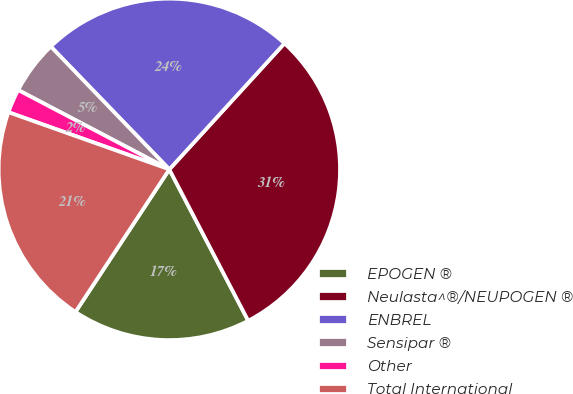<chart> <loc_0><loc_0><loc_500><loc_500><pie_chart><fcel>EPOGEN ®<fcel>Neulasta^®/NEUPOGEN ®<fcel>ENBREL<fcel>Sensipar ®<fcel>Other<fcel>Total International<nl><fcel>16.91%<fcel>30.57%<fcel>24.0%<fcel>5.09%<fcel>2.26%<fcel>21.17%<nl></chart> 